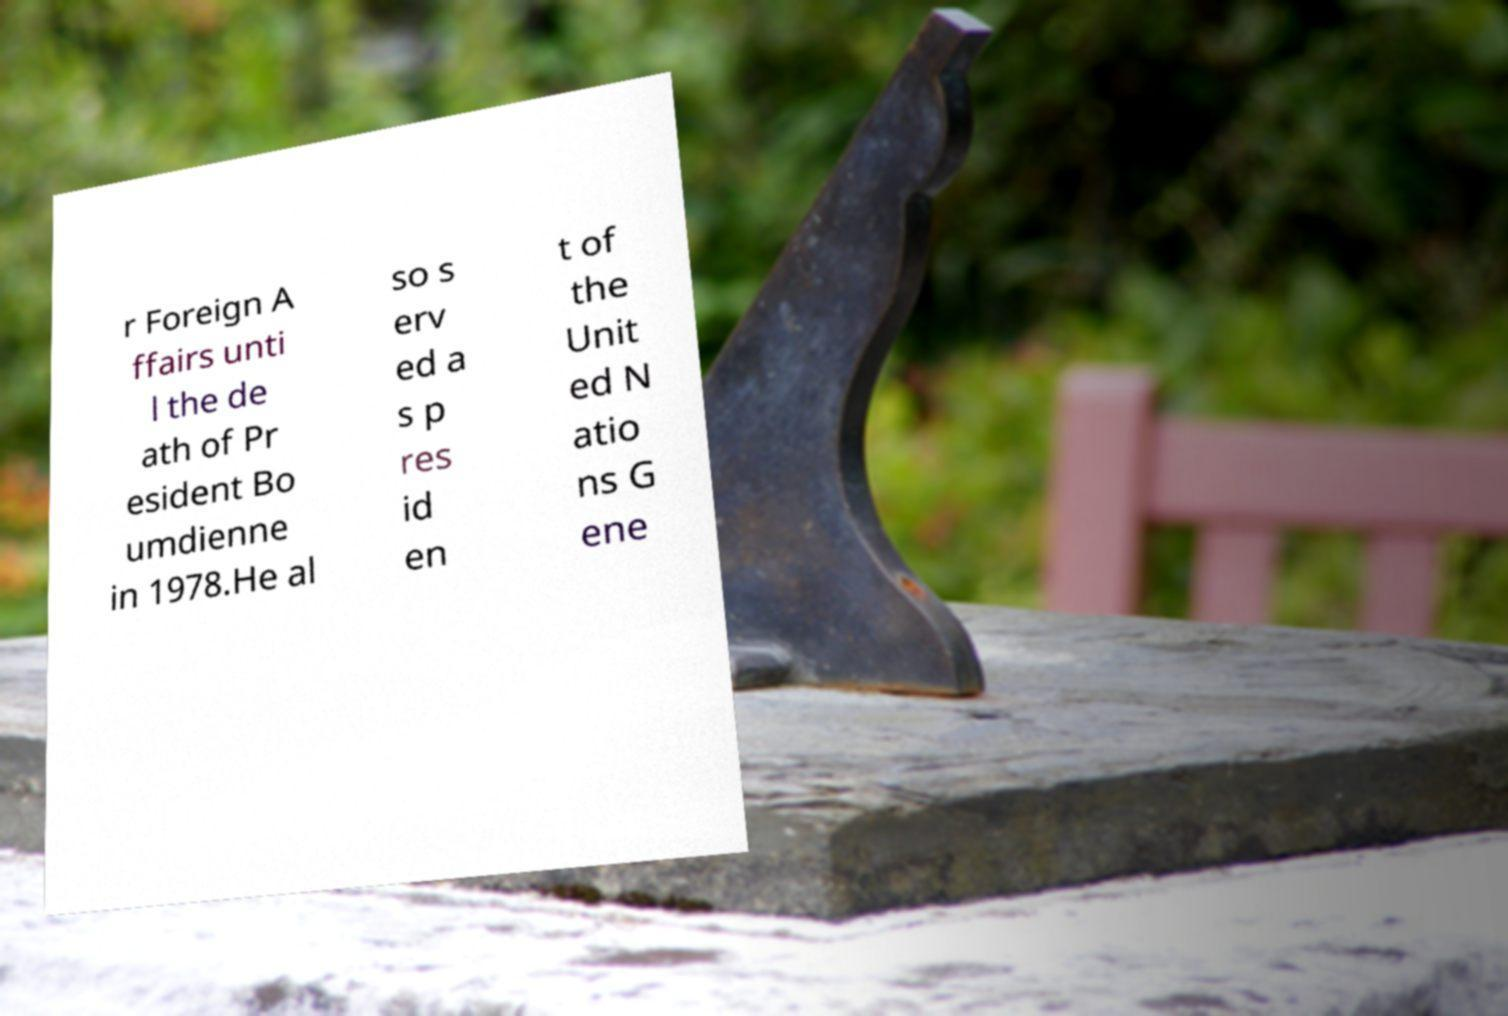Could you assist in decoding the text presented in this image and type it out clearly? r Foreign A ffairs unti l the de ath of Pr esident Bo umdienne in 1978.He al so s erv ed a s p res id en t of the Unit ed N atio ns G ene 